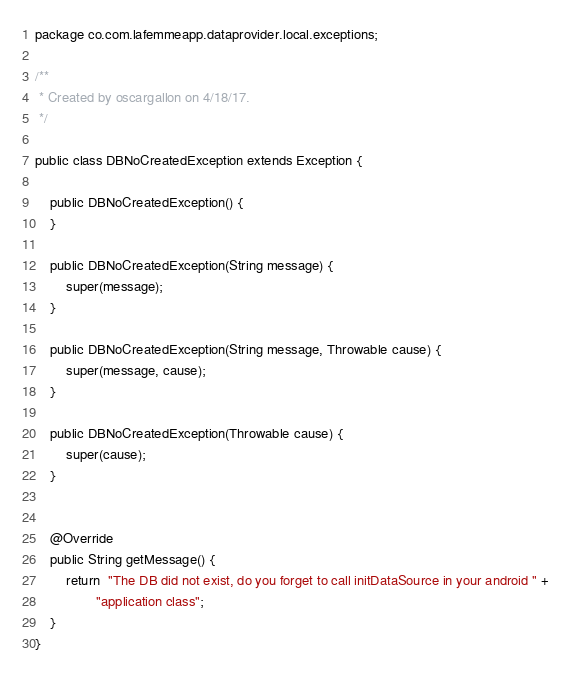Convert code to text. <code><loc_0><loc_0><loc_500><loc_500><_Java_>package co.com.lafemmeapp.dataprovider.local.exceptions;

/**
 * Created by oscargallon on 4/18/17.
 */

public class DBNoCreatedException extends Exception {

    public DBNoCreatedException() {
    }

    public DBNoCreatedException(String message) {
        super(message);
    }

    public DBNoCreatedException(String message, Throwable cause) {
        super(message, cause);
    }

    public DBNoCreatedException(Throwable cause) {
        super(cause);
    }


    @Override
    public String getMessage() {
        return  "The DB did not exist, do you forget to call initDataSource in your android " +
                "application class";
    }
}
</code> 